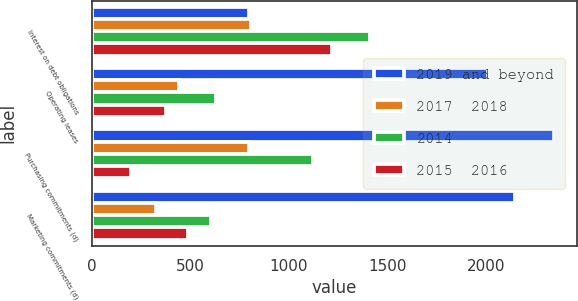Convert chart to OTSL. <chart><loc_0><loc_0><loc_500><loc_500><stacked_bar_chart><ecel><fcel>Interest on debt obligations<fcel>Operating leases<fcel>Purchasing commitments (d)<fcel>Marketing commitments (d)<nl><fcel>2019 and beyond<fcel>798<fcel>2014<fcel>2347<fcel>2149<nl><fcel>2017  2018<fcel>807<fcel>441<fcel>798<fcel>326<nl><fcel>2014<fcel>1411<fcel>631<fcel>1122<fcel>605<nl><fcel>2015  2016<fcel>1221<fcel>375<fcel>196<fcel>485<nl></chart> 